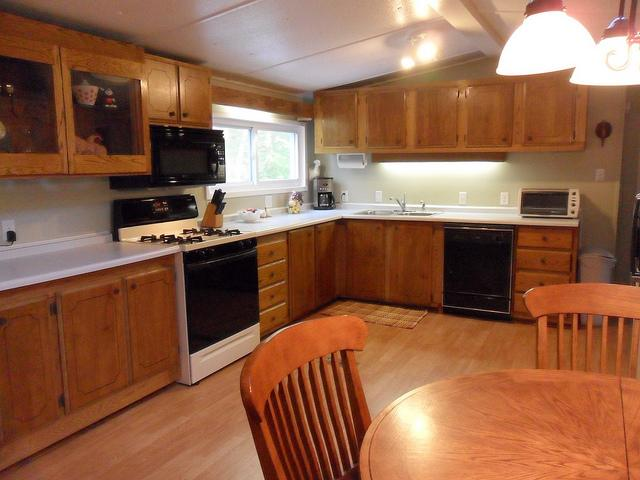What is the silver appliance near the window used to make? coffee 